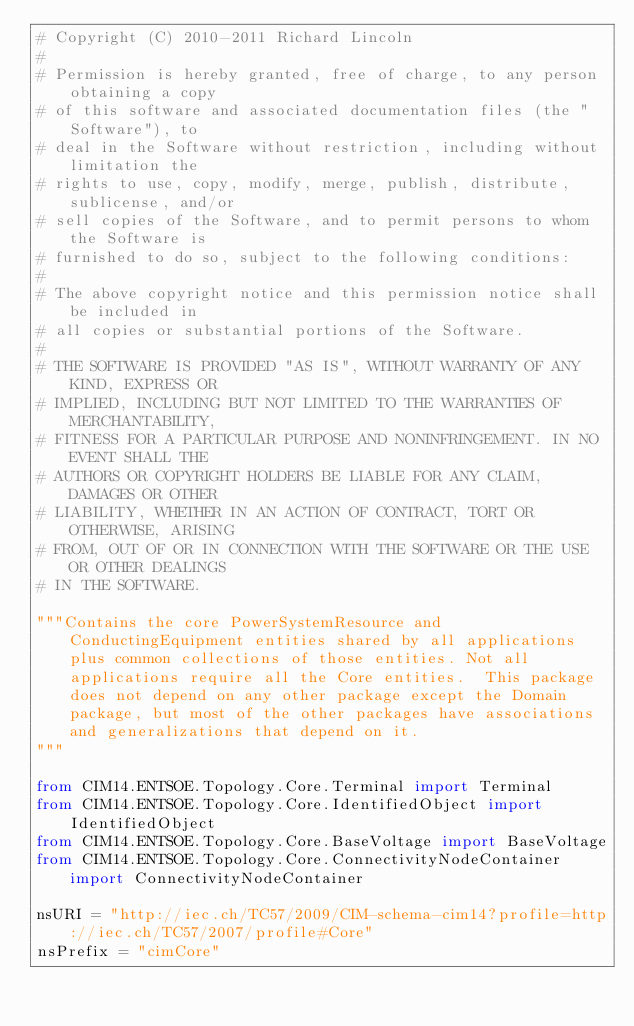Convert code to text. <code><loc_0><loc_0><loc_500><loc_500><_Python_># Copyright (C) 2010-2011 Richard Lincoln
#
# Permission is hereby granted, free of charge, to any person obtaining a copy
# of this software and associated documentation files (the "Software"), to
# deal in the Software without restriction, including without limitation the
# rights to use, copy, modify, merge, publish, distribute, sublicense, and/or
# sell copies of the Software, and to permit persons to whom the Software is
# furnished to do so, subject to the following conditions:
#
# The above copyright notice and this permission notice shall be included in
# all copies or substantial portions of the Software.
#
# THE SOFTWARE IS PROVIDED "AS IS", WITHOUT WARRANTY OF ANY KIND, EXPRESS OR
# IMPLIED, INCLUDING BUT NOT LIMITED TO THE WARRANTIES OF MERCHANTABILITY,
# FITNESS FOR A PARTICULAR PURPOSE AND NONINFRINGEMENT. IN NO EVENT SHALL THE
# AUTHORS OR COPYRIGHT HOLDERS BE LIABLE FOR ANY CLAIM, DAMAGES OR OTHER
# LIABILITY, WHETHER IN AN ACTION OF CONTRACT, TORT OR OTHERWISE, ARISING
# FROM, OUT OF OR IN CONNECTION WITH THE SOFTWARE OR THE USE OR OTHER DEALINGS
# IN THE SOFTWARE.

"""Contains the core PowerSystemResource and ConductingEquipment entities shared by all applications plus common collections of those entities. Not all applications require all the Core entities.  This package does not depend on any other package except the Domain package, but most of the other packages have associations and generalizations that depend on it.
"""

from CIM14.ENTSOE.Topology.Core.Terminal import Terminal
from CIM14.ENTSOE.Topology.Core.IdentifiedObject import IdentifiedObject
from CIM14.ENTSOE.Topology.Core.BaseVoltage import BaseVoltage
from CIM14.ENTSOE.Topology.Core.ConnectivityNodeContainer import ConnectivityNodeContainer

nsURI = "http://iec.ch/TC57/2009/CIM-schema-cim14?profile=http://iec.ch/TC57/2007/profile#Core"
nsPrefix = "cimCore"

</code> 